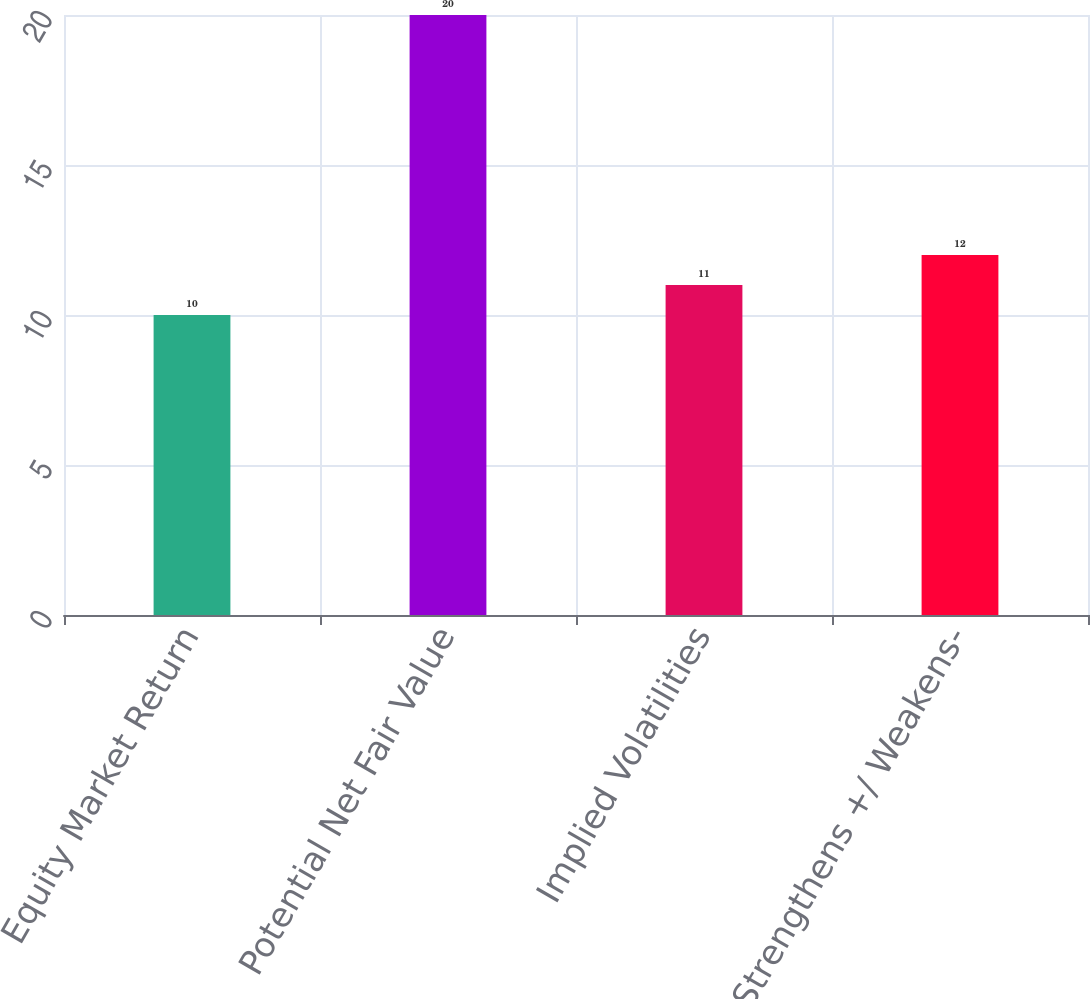Convert chart to OTSL. <chart><loc_0><loc_0><loc_500><loc_500><bar_chart><fcel>Equity Market Return<fcel>Potential Net Fair Value<fcel>Implied Volatilities<fcel>Yen Strengthens +/ Weakens-<nl><fcel>10<fcel>20<fcel>11<fcel>12<nl></chart> 